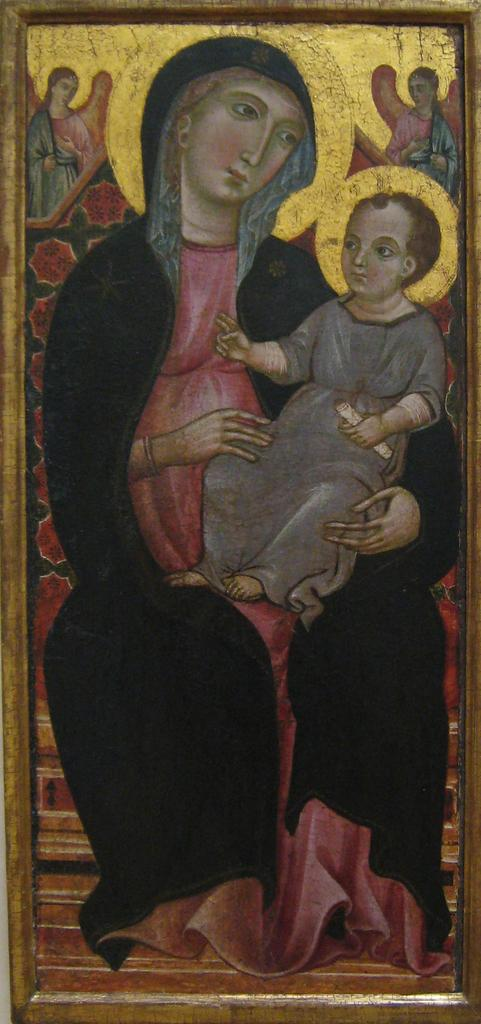What is the main subject of the image? The main subject of the image is an art piece. What does the art piece depict? The art piece depicts persons, including a kid. How does the celery turn in the image? There is no celery present in the image, so it cannot be determined how it might turn. 